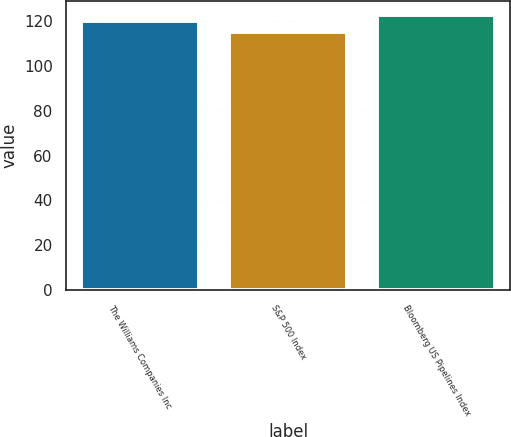Convert chart to OTSL. <chart><loc_0><loc_0><loc_500><loc_500><bar_chart><fcel>The Williams Companies Inc<fcel>S&P 500 Index<fcel>Bloomberg US Pipelines Index<nl><fcel>120.1<fcel>115.1<fcel>123<nl></chart> 